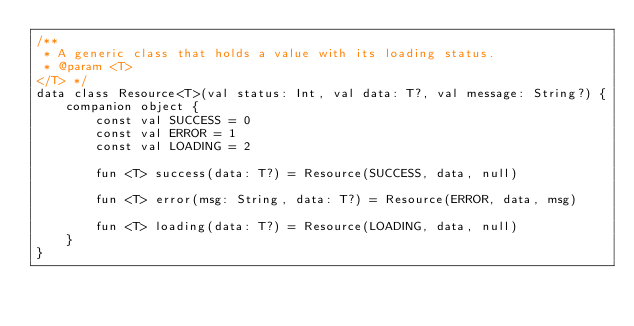Convert code to text. <code><loc_0><loc_0><loc_500><loc_500><_Kotlin_>/**
 * A generic class that holds a value with its loading status.
 * @param <T>
</T> */
data class Resource<T>(val status: Int, val data: T?, val message: String?) {
    companion object {
        const val SUCCESS = 0
        const val ERROR = 1
        const val LOADING = 2

        fun <T> success(data: T?) = Resource(SUCCESS, data, null)

        fun <T> error(msg: String, data: T?) = Resource(ERROR, data, msg)

        fun <T> loading(data: T?) = Resource(LOADING, data, null)
    }
}
</code> 